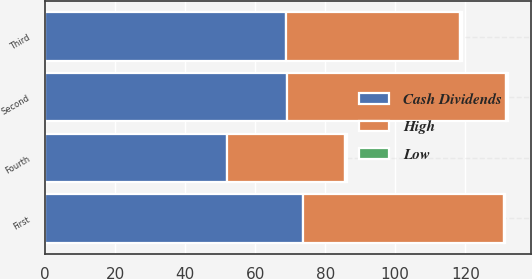<chart> <loc_0><loc_0><loc_500><loc_500><stacked_bar_chart><ecel><fcel>First<fcel>Second<fcel>Third<fcel>Fourth<nl><fcel>Cash Dividends<fcel>73.75<fcel>68.98<fcel>68.76<fcel>51.87<nl><fcel>High<fcel>57.21<fcel>62.75<fcel>49.74<fcel>33.81<nl><fcel>Low<fcel>0.45<fcel>0.45<fcel>0.45<fcel>0.45<nl></chart> 